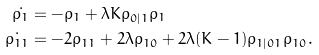<formula> <loc_0><loc_0><loc_500><loc_500>\dot { \rho _ { 1 } } & = - \rho _ { 1 } + \lambda K \rho _ { 0 | 1 } \rho _ { 1 } \\ \dot { \rho _ { 1 1 } } & = - 2 \rho _ { 1 1 } + 2 \lambda \rho _ { 1 0 } + 2 \lambda ( K - 1 ) \rho _ { 1 | 0 1 } \rho _ { 1 0 } .</formula> 